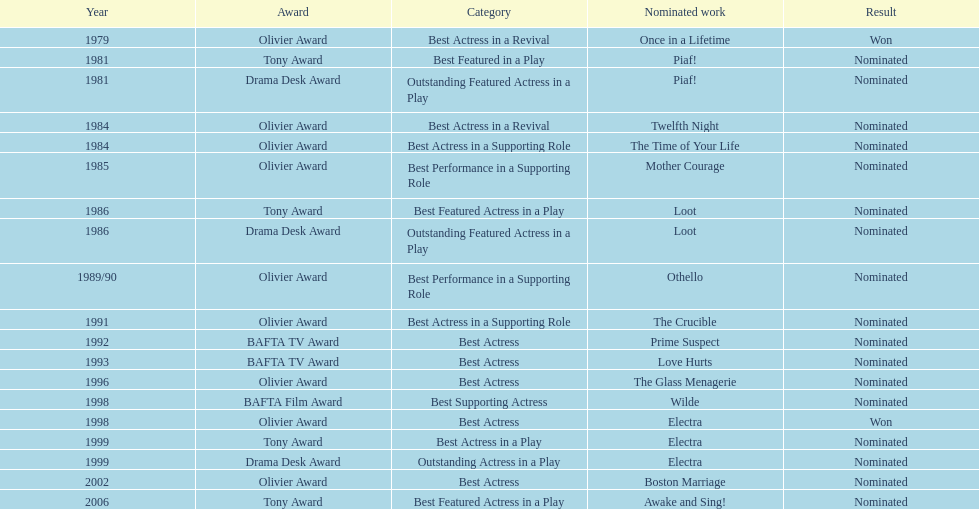What award did once in a lifetime win? Best Actress in a Revival. 